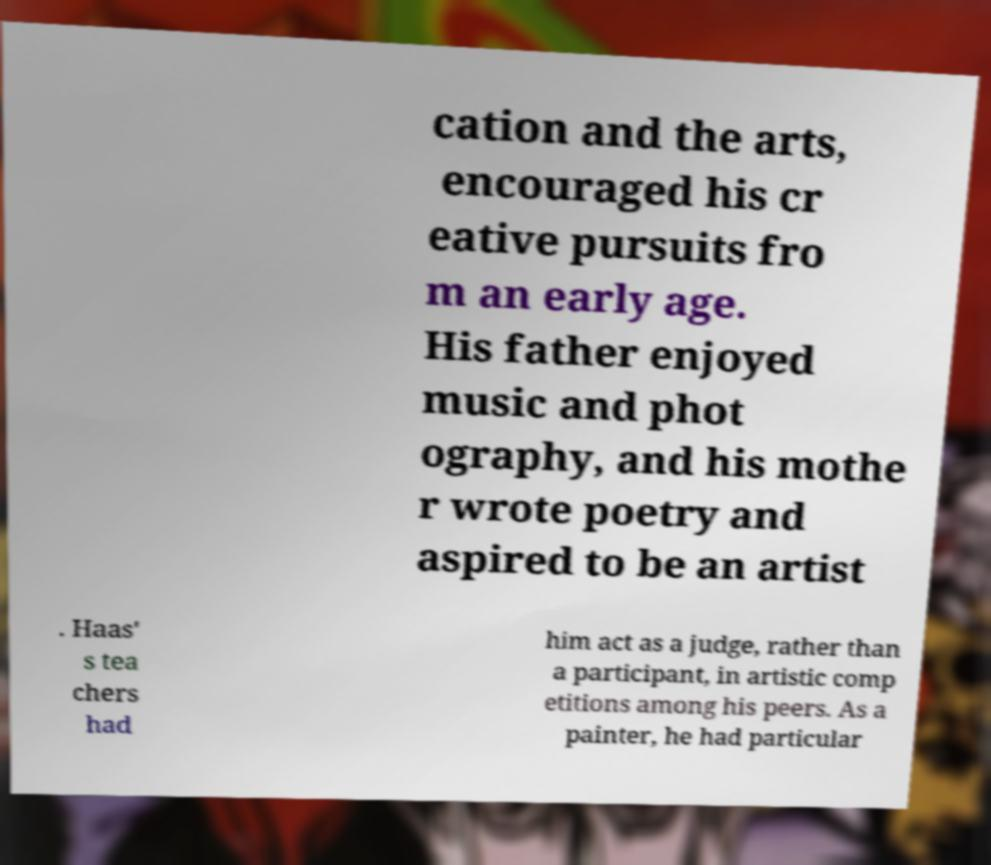Could you extract and type out the text from this image? cation and the arts, encouraged his cr eative pursuits fro m an early age. His father enjoyed music and phot ography, and his mothe r wrote poetry and aspired to be an artist . Haas' s tea chers had him act as a judge, rather than a participant, in artistic comp etitions among his peers. As a painter, he had particular 